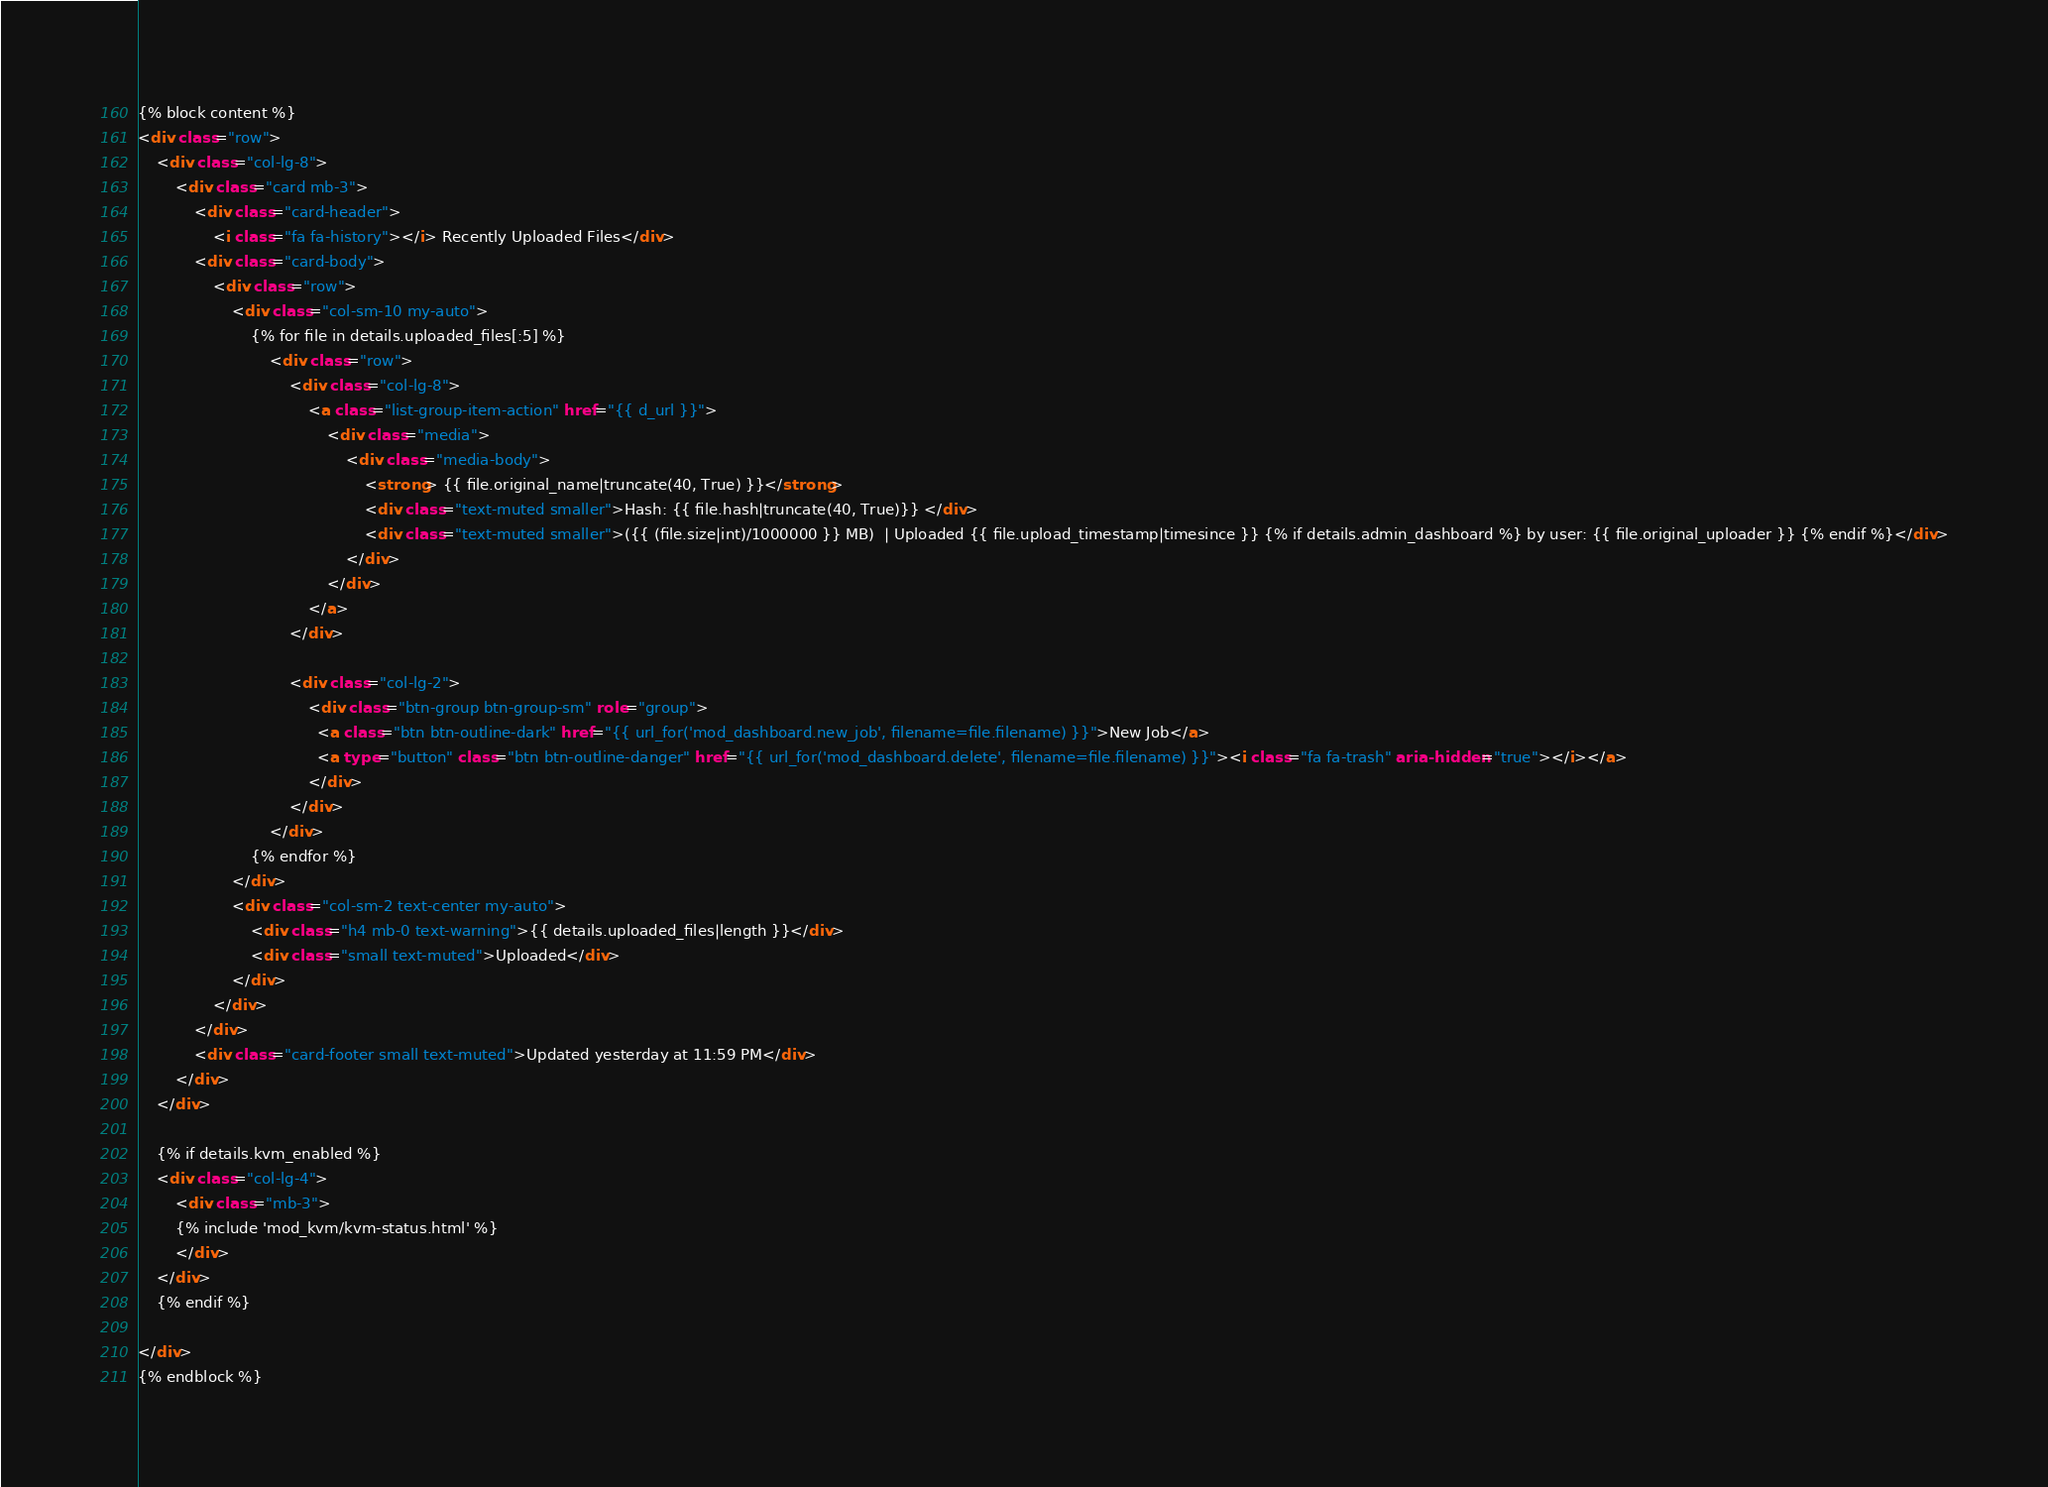<code> <loc_0><loc_0><loc_500><loc_500><_HTML_>{% block content %}
<div class="row">
    <div class="col-lg-8">
        <div class="card mb-3">
            <div class="card-header">
                <i class="fa fa-history"></i> Recently Uploaded Files</div>
            <div class="card-body">
                <div class="row">
                    <div class="col-sm-10 my-auto">
                        {% for file in details.uploaded_files[:5] %}
                            <div class="row">
                                <div class="col-lg-8">
                                    <a class="list-group-item-action" href="{{ d_url }}">
                                        <div class="media">
                                            <div class="media-body">
                                                <strong> {{ file.original_name|truncate(40, True) }}</strong>
                                                <div class="text-muted smaller">Hash: {{ file.hash|truncate(40, True)}} </div>
                                                <div class="text-muted smaller">({{ (file.size|int)/1000000 }} MB)  | Uploaded {{ file.upload_timestamp|timesince }} {% if details.admin_dashboard %} by user: {{ file.original_uploader }} {% endif %}</div>
                                            </div>
                                        </div>
                                    </a>
                                </div>

                                <div class="col-lg-2">
                                    <div class="btn-group btn-group-sm" role="group">
                                      <a class="btn btn-outline-dark" href="{{ url_for('mod_dashboard.new_job', filename=file.filename) }}">New Job</a>
                                      <a type="button" class="btn btn-outline-danger" href="{{ url_for('mod_dashboard.delete', filename=file.filename) }}"><i class="fa fa-trash" aria-hidden="true"></i></a>
                                    </div>
                                </div>
                            </div>
                        {% endfor %}
                    </div>
                    <div class="col-sm-2 text-center my-auto">
                        <div class="h4 mb-0 text-warning">{{ details.uploaded_files|length }}</div>
                        <div class="small text-muted">Uploaded</div>
                    </div>
                </div>
            </div>
            <div class="card-footer small text-muted">Updated yesterday at 11:59 PM</div>
        </div>
    </div>

    {% if details.kvm_enabled %}
    <div class="col-lg-4">
        <div class="mb-3">
        {% include 'mod_kvm/kvm-status.html' %}
        </div>
    </div>
    {% endif %}

</div>
{% endblock %}
</code> 